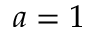<formula> <loc_0><loc_0><loc_500><loc_500>a = 1</formula> 